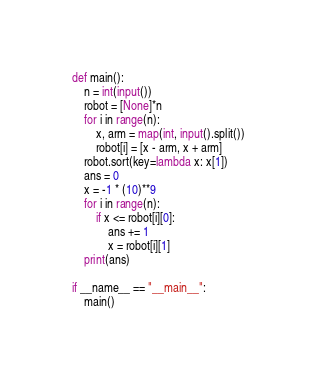<code> <loc_0><loc_0><loc_500><loc_500><_Python_>def main():
    n = int(input())
    robot = [None]*n
    for i in range(n):
        x, arm = map(int, input().split())
        robot[i] = [x - arm, x + arm]
    robot.sort(key=lambda x: x[1])
    ans = 0
    x = -1 * (10)**9
    for i in range(n):
        if x <= robot[i][0]:
            ans += 1
            x = robot[i][1]
    print(ans)

if __name__ == "__main__":
    main()</code> 